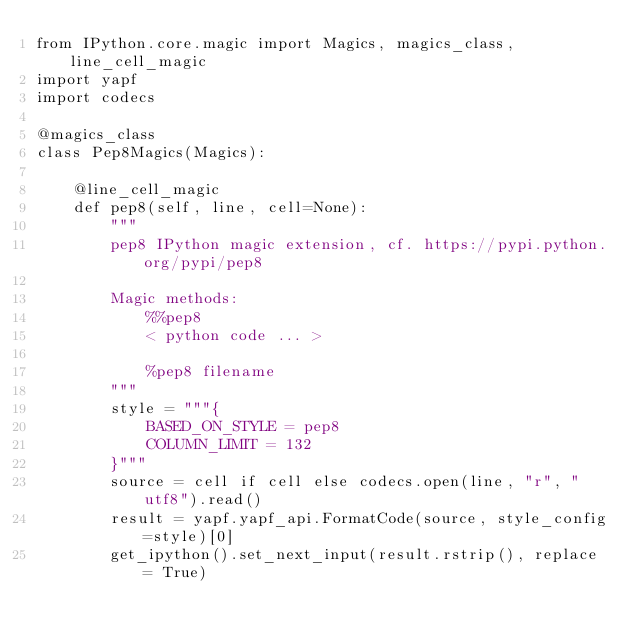<code> <loc_0><loc_0><loc_500><loc_500><_Python_>from IPython.core.magic import Magics, magics_class, line_cell_magic
import yapf
import codecs

@magics_class
class Pep8Magics(Magics):

    @line_cell_magic
    def pep8(self, line, cell=None):
        """
        pep8 IPython magic extension, cf. https://pypi.python.org/pypi/pep8

        Magic methods:
            %%pep8 
            < python code ... >
    
            %pep8 filename
        """
        style = """{
            BASED_ON_STYLE = pep8
            COLUMN_LIMIT = 132
        }"""
        source = cell if cell else codecs.open(line, "r", "utf8").read()
        result = yapf.yapf_api.FormatCode(source, style_config=style)[0]
        get_ipython().set_next_input(result.rstrip(), replace = True)
</code> 